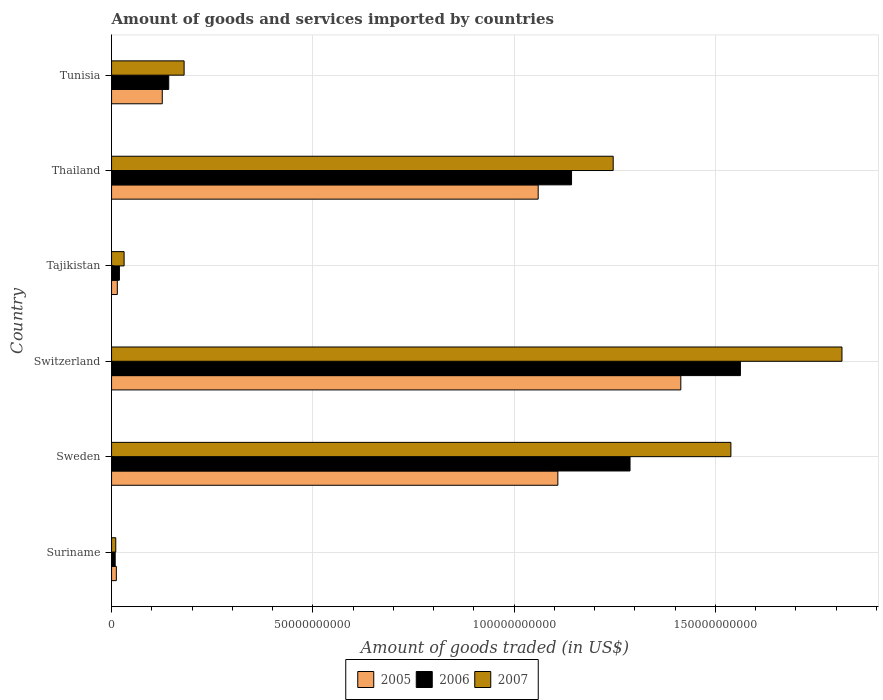How many bars are there on the 6th tick from the bottom?
Provide a short and direct response. 3. What is the label of the 3rd group of bars from the top?
Give a very brief answer. Tajikistan. In how many cases, is the number of bars for a given country not equal to the number of legend labels?
Offer a very short reply. 0. What is the total amount of goods and services imported in 2007 in Suriname?
Provide a short and direct response. 1.04e+09. Across all countries, what is the maximum total amount of goods and services imported in 2007?
Your response must be concise. 1.81e+11. Across all countries, what is the minimum total amount of goods and services imported in 2006?
Give a very brief answer. 9.03e+08. In which country was the total amount of goods and services imported in 2007 maximum?
Give a very brief answer. Switzerland. In which country was the total amount of goods and services imported in 2005 minimum?
Keep it short and to the point. Suriname. What is the total total amount of goods and services imported in 2005 in the graph?
Your response must be concise. 3.73e+11. What is the difference between the total amount of goods and services imported in 2006 in Suriname and that in Tunisia?
Keep it short and to the point. -1.33e+1. What is the difference between the total amount of goods and services imported in 2007 in Suriname and the total amount of goods and services imported in 2005 in Sweden?
Provide a short and direct response. -1.10e+11. What is the average total amount of goods and services imported in 2005 per country?
Offer a terse response. 6.22e+1. What is the difference between the total amount of goods and services imported in 2007 and total amount of goods and services imported in 2006 in Tunisia?
Give a very brief answer. 3.82e+09. What is the ratio of the total amount of goods and services imported in 2006 in Sweden to that in Switzerland?
Ensure brevity in your answer.  0.82. What is the difference between the highest and the second highest total amount of goods and services imported in 2007?
Provide a short and direct response. 2.76e+1. What is the difference between the highest and the lowest total amount of goods and services imported in 2007?
Offer a very short reply. 1.80e+11. In how many countries, is the total amount of goods and services imported in 2007 greater than the average total amount of goods and services imported in 2007 taken over all countries?
Provide a succinct answer. 3. What does the 2nd bar from the top in Switzerland represents?
Your response must be concise. 2006. Is it the case that in every country, the sum of the total amount of goods and services imported in 2006 and total amount of goods and services imported in 2005 is greater than the total amount of goods and services imported in 2007?
Provide a short and direct response. Yes. How many bars are there?
Ensure brevity in your answer.  18. What is the difference between two consecutive major ticks on the X-axis?
Provide a succinct answer. 5.00e+1. Are the values on the major ticks of X-axis written in scientific E-notation?
Offer a terse response. No. Does the graph contain any zero values?
Your answer should be compact. No. How many legend labels are there?
Keep it short and to the point. 3. How are the legend labels stacked?
Make the answer very short. Horizontal. What is the title of the graph?
Keep it short and to the point. Amount of goods and services imported by countries. Does "2015" appear as one of the legend labels in the graph?
Offer a very short reply. No. What is the label or title of the X-axis?
Your answer should be very brief. Amount of goods traded (in US$). What is the Amount of goods traded (in US$) of 2005 in Suriname?
Give a very brief answer. 1.19e+09. What is the Amount of goods traded (in US$) of 2006 in Suriname?
Offer a very short reply. 9.03e+08. What is the Amount of goods traded (in US$) in 2007 in Suriname?
Give a very brief answer. 1.04e+09. What is the Amount of goods traded (in US$) in 2005 in Sweden?
Your response must be concise. 1.11e+11. What is the Amount of goods traded (in US$) in 2006 in Sweden?
Give a very brief answer. 1.29e+11. What is the Amount of goods traded (in US$) of 2007 in Sweden?
Give a very brief answer. 1.54e+11. What is the Amount of goods traded (in US$) of 2005 in Switzerland?
Provide a succinct answer. 1.41e+11. What is the Amount of goods traded (in US$) in 2006 in Switzerland?
Keep it short and to the point. 1.56e+11. What is the Amount of goods traded (in US$) of 2007 in Switzerland?
Keep it short and to the point. 1.81e+11. What is the Amount of goods traded (in US$) in 2005 in Tajikistan?
Your response must be concise. 1.43e+09. What is the Amount of goods traded (in US$) of 2006 in Tajikistan?
Your response must be concise. 1.95e+09. What is the Amount of goods traded (in US$) of 2007 in Tajikistan?
Keep it short and to the point. 3.12e+09. What is the Amount of goods traded (in US$) of 2005 in Thailand?
Make the answer very short. 1.06e+11. What is the Amount of goods traded (in US$) in 2006 in Thailand?
Your response must be concise. 1.14e+11. What is the Amount of goods traded (in US$) of 2007 in Thailand?
Ensure brevity in your answer.  1.25e+11. What is the Amount of goods traded (in US$) in 2005 in Tunisia?
Your answer should be compact. 1.26e+1. What is the Amount of goods traded (in US$) in 2006 in Tunisia?
Make the answer very short. 1.42e+1. What is the Amount of goods traded (in US$) in 2007 in Tunisia?
Offer a terse response. 1.80e+1. Across all countries, what is the maximum Amount of goods traded (in US$) in 2005?
Your answer should be compact. 1.41e+11. Across all countries, what is the maximum Amount of goods traded (in US$) of 2006?
Your answer should be very brief. 1.56e+11. Across all countries, what is the maximum Amount of goods traded (in US$) in 2007?
Offer a very short reply. 1.81e+11. Across all countries, what is the minimum Amount of goods traded (in US$) in 2005?
Ensure brevity in your answer.  1.19e+09. Across all countries, what is the minimum Amount of goods traded (in US$) in 2006?
Your answer should be compact. 9.03e+08. Across all countries, what is the minimum Amount of goods traded (in US$) of 2007?
Your answer should be very brief. 1.04e+09. What is the total Amount of goods traded (in US$) in 2005 in the graph?
Give a very brief answer. 3.73e+11. What is the total Amount of goods traded (in US$) in 2006 in the graph?
Your response must be concise. 4.16e+11. What is the total Amount of goods traded (in US$) in 2007 in the graph?
Your answer should be very brief. 4.82e+11. What is the difference between the Amount of goods traded (in US$) in 2005 in Suriname and that in Sweden?
Ensure brevity in your answer.  -1.10e+11. What is the difference between the Amount of goods traded (in US$) of 2006 in Suriname and that in Sweden?
Provide a succinct answer. -1.28e+11. What is the difference between the Amount of goods traded (in US$) of 2007 in Suriname and that in Sweden?
Provide a succinct answer. -1.53e+11. What is the difference between the Amount of goods traded (in US$) of 2005 in Suriname and that in Switzerland?
Give a very brief answer. -1.40e+11. What is the difference between the Amount of goods traded (in US$) of 2006 in Suriname and that in Switzerland?
Your response must be concise. -1.55e+11. What is the difference between the Amount of goods traded (in US$) of 2007 in Suriname and that in Switzerland?
Give a very brief answer. -1.80e+11. What is the difference between the Amount of goods traded (in US$) in 2005 in Suriname and that in Tajikistan?
Make the answer very short. -2.42e+08. What is the difference between the Amount of goods traded (in US$) in 2006 in Suriname and that in Tajikistan?
Keep it short and to the point. -1.05e+09. What is the difference between the Amount of goods traded (in US$) in 2007 in Suriname and that in Tajikistan?
Give a very brief answer. -2.07e+09. What is the difference between the Amount of goods traded (in US$) in 2005 in Suriname and that in Thailand?
Make the answer very short. -1.05e+11. What is the difference between the Amount of goods traded (in US$) of 2006 in Suriname and that in Thailand?
Ensure brevity in your answer.  -1.13e+11. What is the difference between the Amount of goods traded (in US$) of 2007 in Suriname and that in Thailand?
Your answer should be very brief. -1.24e+11. What is the difference between the Amount of goods traded (in US$) of 2005 in Suriname and that in Tunisia?
Keep it short and to the point. -1.14e+1. What is the difference between the Amount of goods traded (in US$) of 2006 in Suriname and that in Tunisia?
Your response must be concise. -1.33e+1. What is the difference between the Amount of goods traded (in US$) of 2007 in Suriname and that in Tunisia?
Give a very brief answer. -1.70e+1. What is the difference between the Amount of goods traded (in US$) in 2005 in Sweden and that in Switzerland?
Your answer should be compact. -3.05e+1. What is the difference between the Amount of goods traded (in US$) of 2006 in Sweden and that in Switzerland?
Your response must be concise. -2.74e+1. What is the difference between the Amount of goods traded (in US$) of 2007 in Sweden and that in Switzerland?
Your answer should be very brief. -2.76e+1. What is the difference between the Amount of goods traded (in US$) of 2005 in Sweden and that in Tajikistan?
Offer a terse response. 1.09e+11. What is the difference between the Amount of goods traded (in US$) in 2006 in Sweden and that in Tajikistan?
Keep it short and to the point. 1.27e+11. What is the difference between the Amount of goods traded (in US$) in 2007 in Sweden and that in Tajikistan?
Offer a terse response. 1.51e+11. What is the difference between the Amount of goods traded (in US$) of 2005 in Sweden and that in Thailand?
Ensure brevity in your answer.  4.88e+09. What is the difference between the Amount of goods traded (in US$) in 2006 in Sweden and that in Thailand?
Make the answer very short. 1.45e+1. What is the difference between the Amount of goods traded (in US$) of 2007 in Sweden and that in Thailand?
Your response must be concise. 2.92e+1. What is the difference between the Amount of goods traded (in US$) in 2005 in Sweden and that in Tunisia?
Give a very brief answer. 9.83e+1. What is the difference between the Amount of goods traded (in US$) of 2006 in Sweden and that in Tunisia?
Provide a succinct answer. 1.15e+11. What is the difference between the Amount of goods traded (in US$) of 2007 in Sweden and that in Tunisia?
Ensure brevity in your answer.  1.36e+11. What is the difference between the Amount of goods traded (in US$) in 2005 in Switzerland and that in Tajikistan?
Provide a succinct answer. 1.40e+11. What is the difference between the Amount of goods traded (in US$) of 2006 in Switzerland and that in Tajikistan?
Your response must be concise. 1.54e+11. What is the difference between the Amount of goods traded (in US$) of 2007 in Switzerland and that in Tajikistan?
Your response must be concise. 1.78e+11. What is the difference between the Amount of goods traded (in US$) of 2005 in Switzerland and that in Thailand?
Give a very brief answer. 3.54e+1. What is the difference between the Amount of goods traded (in US$) in 2006 in Switzerland and that in Thailand?
Ensure brevity in your answer.  4.20e+1. What is the difference between the Amount of goods traded (in US$) of 2007 in Switzerland and that in Thailand?
Your answer should be very brief. 5.68e+1. What is the difference between the Amount of goods traded (in US$) in 2005 in Switzerland and that in Tunisia?
Offer a very short reply. 1.29e+11. What is the difference between the Amount of goods traded (in US$) in 2006 in Switzerland and that in Tunisia?
Give a very brief answer. 1.42e+11. What is the difference between the Amount of goods traded (in US$) of 2007 in Switzerland and that in Tunisia?
Your answer should be very brief. 1.63e+11. What is the difference between the Amount of goods traded (in US$) of 2005 in Tajikistan and that in Thailand?
Your response must be concise. -1.05e+11. What is the difference between the Amount of goods traded (in US$) of 2006 in Tajikistan and that in Thailand?
Provide a succinct answer. -1.12e+11. What is the difference between the Amount of goods traded (in US$) in 2007 in Tajikistan and that in Thailand?
Your response must be concise. -1.21e+11. What is the difference between the Amount of goods traded (in US$) in 2005 in Tajikistan and that in Tunisia?
Provide a short and direct response. -1.12e+1. What is the difference between the Amount of goods traded (in US$) of 2006 in Tajikistan and that in Tunisia?
Provide a succinct answer. -1.22e+1. What is the difference between the Amount of goods traded (in US$) in 2007 in Tajikistan and that in Tunisia?
Keep it short and to the point. -1.49e+1. What is the difference between the Amount of goods traded (in US$) of 2005 in Thailand and that in Tunisia?
Your response must be concise. 9.34e+1. What is the difference between the Amount of goods traded (in US$) in 2006 in Thailand and that in Tunisia?
Your answer should be compact. 1.00e+11. What is the difference between the Amount of goods traded (in US$) in 2007 in Thailand and that in Tunisia?
Offer a terse response. 1.07e+11. What is the difference between the Amount of goods traded (in US$) of 2005 in Suriname and the Amount of goods traded (in US$) of 2006 in Sweden?
Offer a terse response. -1.28e+11. What is the difference between the Amount of goods traded (in US$) in 2005 in Suriname and the Amount of goods traded (in US$) in 2007 in Sweden?
Your answer should be very brief. -1.53e+11. What is the difference between the Amount of goods traded (in US$) of 2006 in Suriname and the Amount of goods traded (in US$) of 2007 in Sweden?
Keep it short and to the point. -1.53e+11. What is the difference between the Amount of goods traded (in US$) of 2005 in Suriname and the Amount of goods traded (in US$) of 2006 in Switzerland?
Provide a short and direct response. -1.55e+11. What is the difference between the Amount of goods traded (in US$) of 2005 in Suriname and the Amount of goods traded (in US$) of 2007 in Switzerland?
Your answer should be very brief. -1.80e+11. What is the difference between the Amount of goods traded (in US$) of 2006 in Suriname and the Amount of goods traded (in US$) of 2007 in Switzerland?
Provide a short and direct response. -1.81e+11. What is the difference between the Amount of goods traded (in US$) of 2005 in Suriname and the Amount of goods traded (in US$) of 2006 in Tajikistan?
Provide a short and direct response. -7.65e+08. What is the difference between the Amount of goods traded (in US$) of 2005 in Suriname and the Amount of goods traded (in US$) of 2007 in Tajikistan?
Provide a short and direct response. -1.93e+09. What is the difference between the Amount of goods traded (in US$) of 2006 in Suriname and the Amount of goods traded (in US$) of 2007 in Tajikistan?
Your answer should be very brief. -2.21e+09. What is the difference between the Amount of goods traded (in US$) of 2005 in Suriname and the Amount of goods traded (in US$) of 2006 in Thailand?
Your answer should be very brief. -1.13e+11. What is the difference between the Amount of goods traded (in US$) in 2005 in Suriname and the Amount of goods traded (in US$) in 2007 in Thailand?
Your answer should be compact. -1.23e+11. What is the difference between the Amount of goods traded (in US$) in 2006 in Suriname and the Amount of goods traded (in US$) in 2007 in Thailand?
Your answer should be compact. -1.24e+11. What is the difference between the Amount of goods traded (in US$) of 2005 in Suriname and the Amount of goods traded (in US$) of 2006 in Tunisia?
Your answer should be compact. -1.30e+1. What is the difference between the Amount of goods traded (in US$) in 2005 in Suriname and the Amount of goods traded (in US$) in 2007 in Tunisia?
Offer a terse response. -1.68e+1. What is the difference between the Amount of goods traded (in US$) in 2006 in Suriname and the Amount of goods traded (in US$) in 2007 in Tunisia?
Your response must be concise. -1.71e+1. What is the difference between the Amount of goods traded (in US$) of 2005 in Sweden and the Amount of goods traded (in US$) of 2006 in Switzerland?
Offer a very short reply. -4.54e+1. What is the difference between the Amount of goods traded (in US$) in 2005 in Sweden and the Amount of goods traded (in US$) in 2007 in Switzerland?
Make the answer very short. -7.06e+1. What is the difference between the Amount of goods traded (in US$) in 2006 in Sweden and the Amount of goods traded (in US$) in 2007 in Switzerland?
Provide a short and direct response. -5.26e+1. What is the difference between the Amount of goods traded (in US$) of 2005 in Sweden and the Amount of goods traded (in US$) of 2006 in Tajikistan?
Your answer should be very brief. 1.09e+11. What is the difference between the Amount of goods traded (in US$) in 2005 in Sweden and the Amount of goods traded (in US$) in 2007 in Tajikistan?
Provide a succinct answer. 1.08e+11. What is the difference between the Amount of goods traded (in US$) in 2006 in Sweden and the Amount of goods traded (in US$) in 2007 in Tajikistan?
Keep it short and to the point. 1.26e+11. What is the difference between the Amount of goods traded (in US$) of 2005 in Sweden and the Amount of goods traded (in US$) of 2006 in Thailand?
Keep it short and to the point. -3.41e+09. What is the difference between the Amount of goods traded (in US$) of 2005 in Sweden and the Amount of goods traded (in US$) of 2007 in Thailand?
Keep it short and to the point. -1.38e+1. What is the difference between the Amount of goods traded (in US$) in 2006 in Sweden and the Amount of goods traded (in US$) in 2007 in Thailand?
Provide a succinct answer. 4.18e+09. What is the difference between the Amount of goods traded (in US$) in 2005 in Sweden and the Amount of goods traded (in US$) in 2006 in Tunisia?
Your answer should be compact. 9.67e+1. What is the difference between the Amount of goods traded (in US$) in 2005 in Sweden and the Amount of goods traded (in US$) in 2007 in Tunisia?
Your answer should be compact. 9.28e+1. What is the difference between the Amount of goods traded (in US$) of 2006 in Sweden and the Amount of goods traded (in US$) of 2007 in Tunisia?
Offer a terse response. 1.11e+11. What is the difference between the Amount of goods traded (in US$) in 2005 in Switzerland and the Amount of goods traded (in US$) in 2006 in Tajikistan?
Provide a short and direct response. 1.39e+11. What is the difference between the Amount of goods traded (in US$) in 2005 in Switzerland and the Amount of goods traded (in US$) in 2007 in Tajikistan?
Ensure brevity in your answer.  1.38e+11. What is the difference between the Amount of goods traded (in US$) in 2006 in Switzerland and the Amount of goods traded (in US$) in 2007 in Tajikistan?
Keep it short and to the point. 1.53e+11. What is the difference between the Amount of goods traded (in US$) of 2005 in Switzerland and the Amount of goods traded (in US$) of 2006 in Thailand?
Your answer should be very brief. 2.71e+1. What is the difference between the Amount of goods traded (in US$) of 2005 in Switzerland and the Amount of goods traded (in US$) of 2007 in Thailand?
Give a very brief answer. 1.68e+1. What is the difference between the Amount of goods traded (in US$) of 2006 in Switzerland and the Amount of goods traded (in US$) of 2007 in Thailand?
Provide a succinct answer. 3.16e+1. What is the difference between the Amount of goods traded (in US$) of 2005 in Switzerland and the Amount of goods traded (in US$) of 2006 in Tunisia?
Make the answer very short. 1.27e+11. What is the difference between the Amount of goods traded (in US$) in 2005 in Switzerland and the Amount of goods traded (in US$) in 2007 in Tunisia?
Your answer should be very brief. 1.23e+11. What is the difference between the Amount of goods traded (in US$) in 2006 in Switzerland and the Amount of goods traded (in US$) in 2007 in Tunisia?
Keep it short and to the point. 1.38e+11. What is the difference between the Amount of goods traded (in US$) in 2005 in Tajikistan and the Amount of goods traded (in US$) in 2006 in Thailand?
Provide a succinct answer. -1.13e+11. What is the difference between the Amount of goods traded (in US$) of 2005 in Tajikistan and the Amount of goods traded (in US$) of 2007 in Thailand?
Your response must be concise. -1.23e+11. What is the difference between the Amount of goods traded (in US$) in 2006 in Tajikistan and the Amount of goods traded (in US$) in 2007 in Thailand?
Ensure brevity in your answer.  -1.23e+11. What is the difference between the Amount of goods traded (in US$) of 2005 in Tajikistan and the Amount of goods traded (in US$) of 2006 in Tunisia?
Your answer should be compact. -1.28e+1. What is the difference between the Amount of goods traded (in US$) in 2005 in Tajikistan and the Amount of goods traded (in US$) in 2007 in Tunisia?
Keep it short and to the point. -1.66e+1. What is the difference between the Amount of goods traded (in US$) in 2006 in Tajikistan and the Amount of goods traded (in US$) in 2007 in Tunisia?
Ensure brevity in your answer.  -1.61e+1. What is the difference between the Amount of goods traded (in US$) in 2005 in Thailand and the Amount of goods traded (in US$) in 2006 in Tunisia?
Offer a very short reply. 9.18e+1. What is the difference between the Amount of goods traded (in US$) of 2005 in Thailand and the Amount of goods traded (in US$) of 2007 in Tunisia?
Ensure brevity in your answer.  8.80e+1. What is the difference between the Amount of goods traded (in US$) in 2006 in Thailand and the Amount of goods traded (in US$) in 2007 in Tunisia?
Keep it short and to the point. 9.62e+1. What is the average Amount of goods traded (in US$) of 2005 per country?
Ensure brevity in your answer.  6.22e+1. What is the average Amount of goods traded (in US$) of 2006 per country?
Offer a very short reply. 6.94e+1. What is the average Amount of goods traded (in US$) in 2007 per country?
Provide a short and direct response. 8.03e+1. What is the difference between the Amount of goods traded (in US$) of 2005 and Amount of goods traded (in US$) of 2006 in Suriname?
Your answer should be compact. 2.86e+08. What is the difference between the Amount of goods traded (in US$) in 2005 and Amount of goods traded (in US$) in 2007 in Suriname?
Offer a very short reply. 1.44e+08. What is the difference between the Amount of goods traded (in US$) in 2006 and Amount of goods traded (in US$) in 2007 in Suriname?
Make the answer very short. -1.42e+08. What is the difference between the Amount of goods traded (in US$) in 2005 and Amount of goods traded (in US$) in 2006 in Sweden?
Offer a very short reply. -1.79e+1. What is the difference between the Amount of goods traded (in US$) in 2005 and Amount of goods traded (in US$) in 2007 in Sweden?
Give a very brief answer. -4.30e+1. What is the difference between the Amount of goods traded (in US$) of 2006 and Amount of goods traded (in US$) of 2007 in Sweden?
Your response must be concise. -2.51e+1. What is the difference between the Amount of goods traded (in US$) of 2005 and Amount of goods traded (in US$) of 2006 in Switzerland?
Provide a short and direct response. -1.48e+1. What is the difference between the Amount of goods traded (in US$) of 2005 and Amount of goods traded (in US$) of 2007 in Switzerland?
Ensure brevity in your answer.  -4.00e+1. What is the difference between the Amount of goods traded (in US$) of 2006 and Amount of goods traded (in US$) of 2007 in Switzerland?
Offer a terse response. -2.52e+1. What is the difference between the Amount of goods traded (in US$) in 2005 and Amount of goods traded (in US$) in 2006 in Tajikistan?
Offer a terse response. -5.24e+08. What is the difference between the Amount of goods traded (in US$) in 2005 and Amount of goods traded (in US$) in 2007 in Tajikistan?
Make the answer very short. -1.68e+09. What is the difference between the Amount of goods traded (in US$) of 2006 and Amount of goods traded (in US$) of 2007 in Tajikistan?
Keep it short and to the point. -1.16e+09. What is the difference between the Amount of goods traded (in US$) of 2005 and Amount of goods traded (in US$) of 2006 in Thailand?
Offer a very short reply. -8.29e+09. What is the difference between the Amount of goods traded (in US$) of 2005 and Amount of goods traded (in US$) of 2007 in Thailand?
Ensure brevity in your answer.  -1.86e+1. What is the difference between the Amount of goods traded (in US$) of 2006 and Amount of goods traded (in US$) of 2007 in Thailand?
Ensure brevity in your answer.  -1.03e+1. What is the difference between the Amount of goods traded (in US$) in 2005 and Amount of goods traded (in US$) in 2006 in Tunisia?
Keep it short and to the point. -1.61e+09. What is the difference between the Amount of goods traded (in US$) of 2005 and Amount of goods traded (in US$) of 2007 in Tunisia?
Offer a very short reply. -5.43e+09. What is the difference between the Amount of goods traded (in US$) of 2006 and Amount of goods traded (in US$) of 2007 in Tunisia?
Your answer should be very brief. -3.82e+09. What is the ratio of the Amount of goods traded (in US$) of 2005 in Suriname to that in Sweden?
Ensure brevity in your answer.  0.01. What is the ratio of the Amount of goods traded (in US$) in 2006 in Suriname to that in Sweden?
Your response must be concise. 0.01. What is the ratio of the Amount of goods traded (in US$) of 2007 in Suriname to that in Sweden?
Your response must be concise. 0.01. What is the ratio of the Amount of goods traded (in US$) in 2005 in Suriname to that in Switzerland?
Make the answer very short. 0.01. What is the ratio of the Amount of goods traded (in US$) of 2006 in Suriname to that in Switzerland?
Make the answer very short. 0.01. What is the ratio of the Amount of goods traded (in US$) of 2007 in Suriname to that in Switzerland?
Your response must be concise. 0.01. What is the ratio of the Amount of goods traded (in US$) in 2005 in Suriname to that in Tajikistan?
Give a very brief answer. 0.83. What is the ratio of the Amount of goods traded (in US$) of 2006 in Suriname to that in Tajikistan?
Your answer should be compact. 0.46. What is the ratio of the Amount of goods traded (in US$) of 2007 in Suriname to that in Tajikistan?
Make the answer very short. 0.34. What is the ratio of the Amount of goods traded (in US$) in 2005 in Suriname to that in Thailand?
Provide a short and direct response. 0.01. What is the ratio of the Amount of goods traded (in US$) of 2006 in Suriname to that in Thailand?
Provide a succinct answer. 0.01. What is the ratio of the Amount of goods traded (in US$) in 2007 in Suriname to that in Thailand?
Ensure brevity in your answer.  0.01. What is the ratio of the Amount of goods traded (in US$) of 2005 in Suriname to that in Tunisia?
Your answer should be very brief. 0.09. What is the ratio of the Amount of goods traded (in US$) in 2006 in Suriname to that in Tunisia?
Provide a succinct answer. 0.06. What is the ratio of the Amount of goods traded (in US$) in 2007 in Suriname to that in Tunisia?
Give a very brief answer. 0.06. What is the ratio of the Amount of goods traded (in US$) in 2005 in Sweden to that in Switzerland?
Make the answer very short. 0.78. What is the ratio of the Amount of goods traded (in US$) in 2006 in Sweden to that in Switzerland?
Ensure brevity in your answer.  0.82. What is the ratio of the Amount of goods traded (in US$) in 2007 in Sweden to that in Switzerland?
Your answer should be compact. 0.85. What is the ratio of the Amount of goods traded (in US$) in 2005 in Sweden to that in Tajikistan?
Offer a very short reply. 77.47. What is the ratio of the Amount of goods traded (in US$) of 2006 in Sweden to that in Tajikistan?
Provide a short and direct response. 65.89. What is the ratio of the Amount of goods traded (in US$) of 2007 in Sweden to that in Tajikistan?
Provide a short and direct response. 49.39. What is the ratio of the Amount of goods traded (in US$) in 2005 in Sweden to that in Thailand?
Provide a short and direct response. 1.05. What is the ratio of the Amount of goods traded (in US$) in 2006 in Sweden to that in Thailand?
Your response must be concise. 1.13. What is the ratio of the Amount of goods traded (in US$) of 2007 in Sweden to that in Thailand?
Keep it short and to the point. 1.23. What is the ratio of the Amount of goods traded (in US$) in 2005 in Sweden to that in Tunisia?
Provide a succinct answer. 8.8. What is the ratio of the Amount of goods traded (in US$) of 2006 in Sweden to that in Tunisia?
Offer a terse response. 9.07. What is the ratio of the Amount of goods traded (in US$) in 2007 in Sweden to that in Tunisia?
Offer a terse response. 8.54. What is the ratio of the Amount of goods traded (in US$) of 2005 in Switzerland to that in Tajikistan?
Your answer should be compact. 98.82. What is the ratio of the Amount of goods traded (in US$) of 2006 in Switzerland to that in Tajikistan?
Offer a terse response. 79.92. What is the ratio of the Amount of goods traded (in US$) in 2007 in Switzerland to that in Tajikistan?
Offer a terse response. 58.25. What is the ratio of the Amount of goods traded (in US$) of 2005 in Switzerland to that in Thailand?
Offer a very short reply. 1.33. What is the ratio of the Amount of goods traded (in US$) of 2006 in Switzerland to that in Thailand?
Make the answer very short. 1.37. What is the ratio of the Amount of goods traded (in US$) of 2007 in Switzerland to that in Thailand?
Offer a terse response. 1.46. What is the ratio of the Amount of goods traded (in US$) in 2005 in Switzerland to that in Tunisia?
Keep it short and to the point. 11.23. What is the ratio of the Amount of goods traded (in US$) of 2006 in Switzerland to that in Tunisia?
Ensure brevity in your answer.  11. What is the ratio of the Amount of goods traded (in US$) of 2007 in Switzerland to that in Tunisia?
Your answer should be very brief. 10.07. What is the ratio of the Amount of goods traded (in US$) of 2005 in Tajikistan to that in Thailand?
Offer a terse response. 0.01. What is the ratio of the Amount of goods traded (in US$) in 2006 in Tajikistan to that in Thailand?
Provide a short and direct response. 0.02. What is the ratio of the Amount of goods traded (in US$) in 2007 in Tajikistan to that in Thailand?
Your answer should be compact. 0.03. What is the ratio of the Amount of goods traded (in US$) of 2005 in Tajikistan to that in Tunisia?
Offer a very short reply. 0.11. What is the ratio of the Amount of goods traded (in US$) of 2006 in Tajikistan to that in Tunisia?
Give a very brief answer. 0.14. What is the ratio of the Amount of goods traded (in US$) in 2007 in Tajikistan to that in Tunisia?
Make the answer very short. 0.17. What is the ratio of the Amount of goods traded (in US$) of 2005 in Thailand to that in Tunisia?
Provide a short and direct response. 8.41. What is the ratio of the Amount of goods traded (in US$) of 2006 in Thailand to that in Tunisia?
Make the answer very short. 8.05. What is the ratio of the Amount of goods traded (in US$) of 2007 in Thailand to that in Tunisia?
Offer a terse response. 6.91. What is the difference between the highest and the second highest Amount of goods traded (in US$) of 2005?
Your response must be concise. 3.05e+1. What is the difference between the highest and the second highest Amount of goods traded (in US$) in 2006?
Give a very brief answer. 2.74e+1. What is the difference between the highest and the second highest Amount of goods traded (in US$) in 2007?
Give a very brief answer. 2.76e+1. What is the difference between the highest and the lowest Amount of goods traded (in US$) of 2005?
Your answer should be very brief. 1.40e+11. What is the difference between the highest and the lowest Amount of goods traded (in US$) of 2006?
Your answer should be very brief. 1.55e+11. What is the difference between the highest and the lowest Amount of goods traded (in US$) of 2007?
Your answer should be very brief. 1.80e+11. 